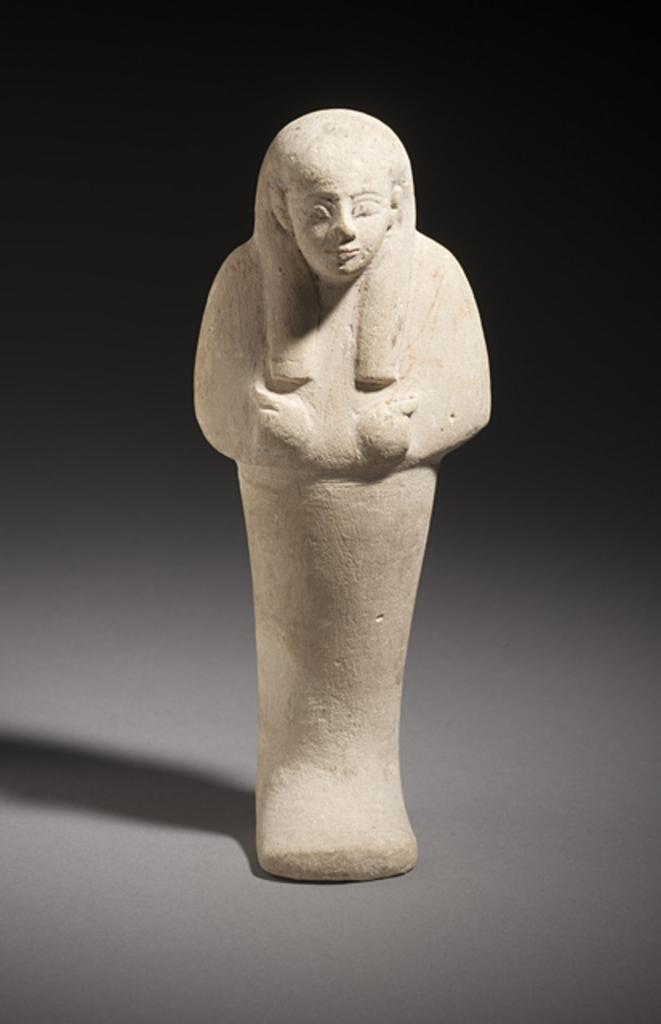What is the main subject of the image? The main subject of the image is a statue. Where is the statue located? The statue is on a surface. What can be observed about the background of the image? The background of the image is dark. What type of mint is growing near the statue in the image? There is no mint present in the image; it only features a statue on a surface with a dark background. 